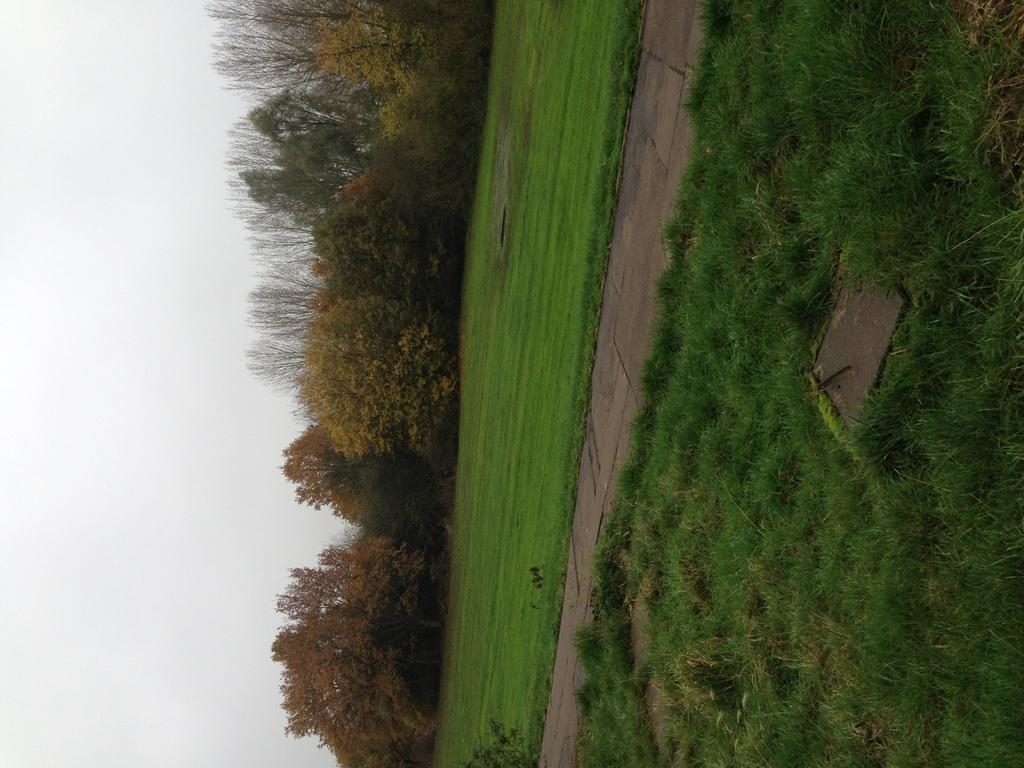What type of surface can be seen in the image? There is a road in the image. What type of vegetation is visible in the image? There is grass and trees visible in the image. What is visible in the background of the image? The sky is visible in the background of the image. What country is depicted in the image? There is no specific country depicted in the image; it shows a road, grass, trees, and the sky. 